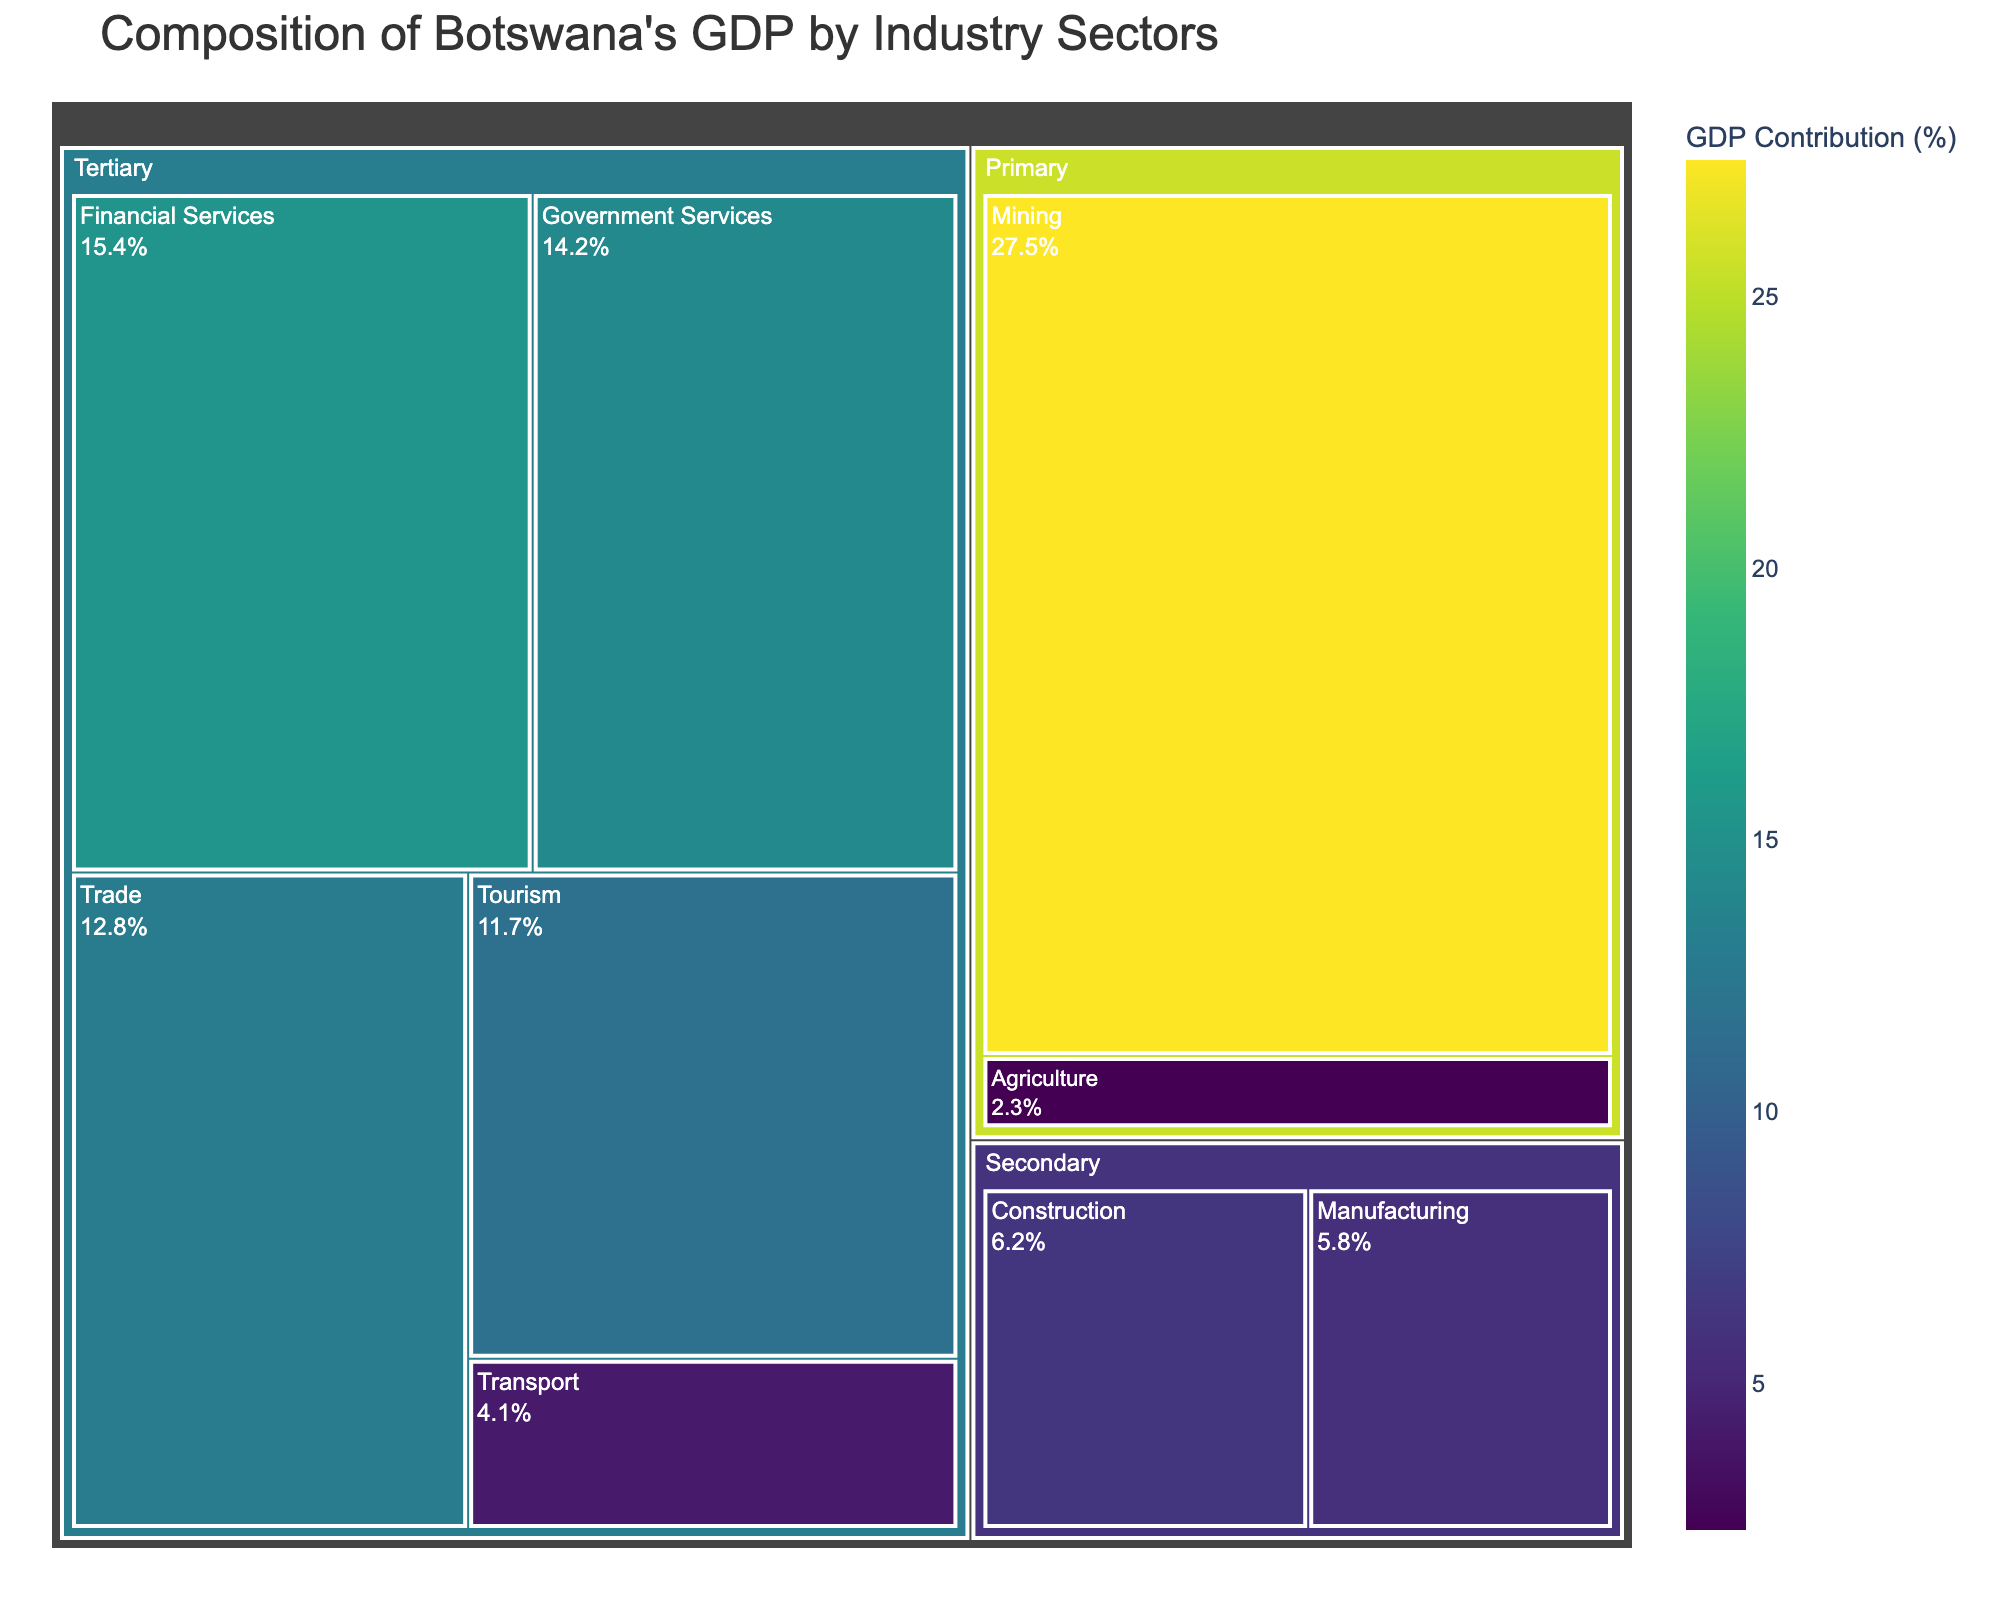What's the title of the figure? The title is displayed prominently at the top of the figure. It conveys the subject of the treemap concerning Botswana's GDP by industry sectors.
Answer: Composition of Botswana's GDP by Industry Sectors Which industry sector contributes the most to Botswana's GDP? By observing the size of the sections in relation to each other, the largest section indicates the highest contribution. The mining industry in the Primary sector is the largest.
Answer: Mining What percentage of Botswana's GDP does agriculture contribute? The agriculture section within the Primary sector is clearly marked with its percentage.
Answer: 2.3% What are the two largest contributors to the tertiary sector? The tertiary sector contains multiple subsections. By comparing their sizes, Financial Services and Government Services are the largest.
Answer: Financial Services, Government Services What is the combined contribution of Mining and Agriculture to Botswana's GDP? Add the GDP contributions of Mining (27.5%) and Agriculture (2.3%) together. This involves a simple sum operation.
Answer: 29.8% Which sector has the smallest contribution to Botswana's GDP? By observing all sections, the smallest one represents the industry with the lowest GDP contribution. Agriculture is the smallest.
Answer: Agriculture How much more does Tourism contribute compared to Transport? Subtract the contribution percentage of Transport (4.1%) from that of Tourism (11.7%) to find the difference.
Answer: 7.6% What percentage of Botswana's GDP is contributed by the Secondary sector? Add the contributions of Manufacturing (5.8%) and Construction (6.2%), these are the industries listed under the Secondary sector.
Answer: 12.0% Which sector has more diversified contributions: Primary, Secondary, or Tertiary? The number of different subsections within each sector indicates diversification. The Tertiary sector has the most individual industries listed.
Answer: Tertiary Is the contribution of Financial Services greater than the combined contribution of Manufacturing and Trade? Compare Financial Services (15.4%) to the combined total of Manufacturing (5.8%) and Trade (12.8%). The combined total is 18.6%, which is greater.
Answer: No 